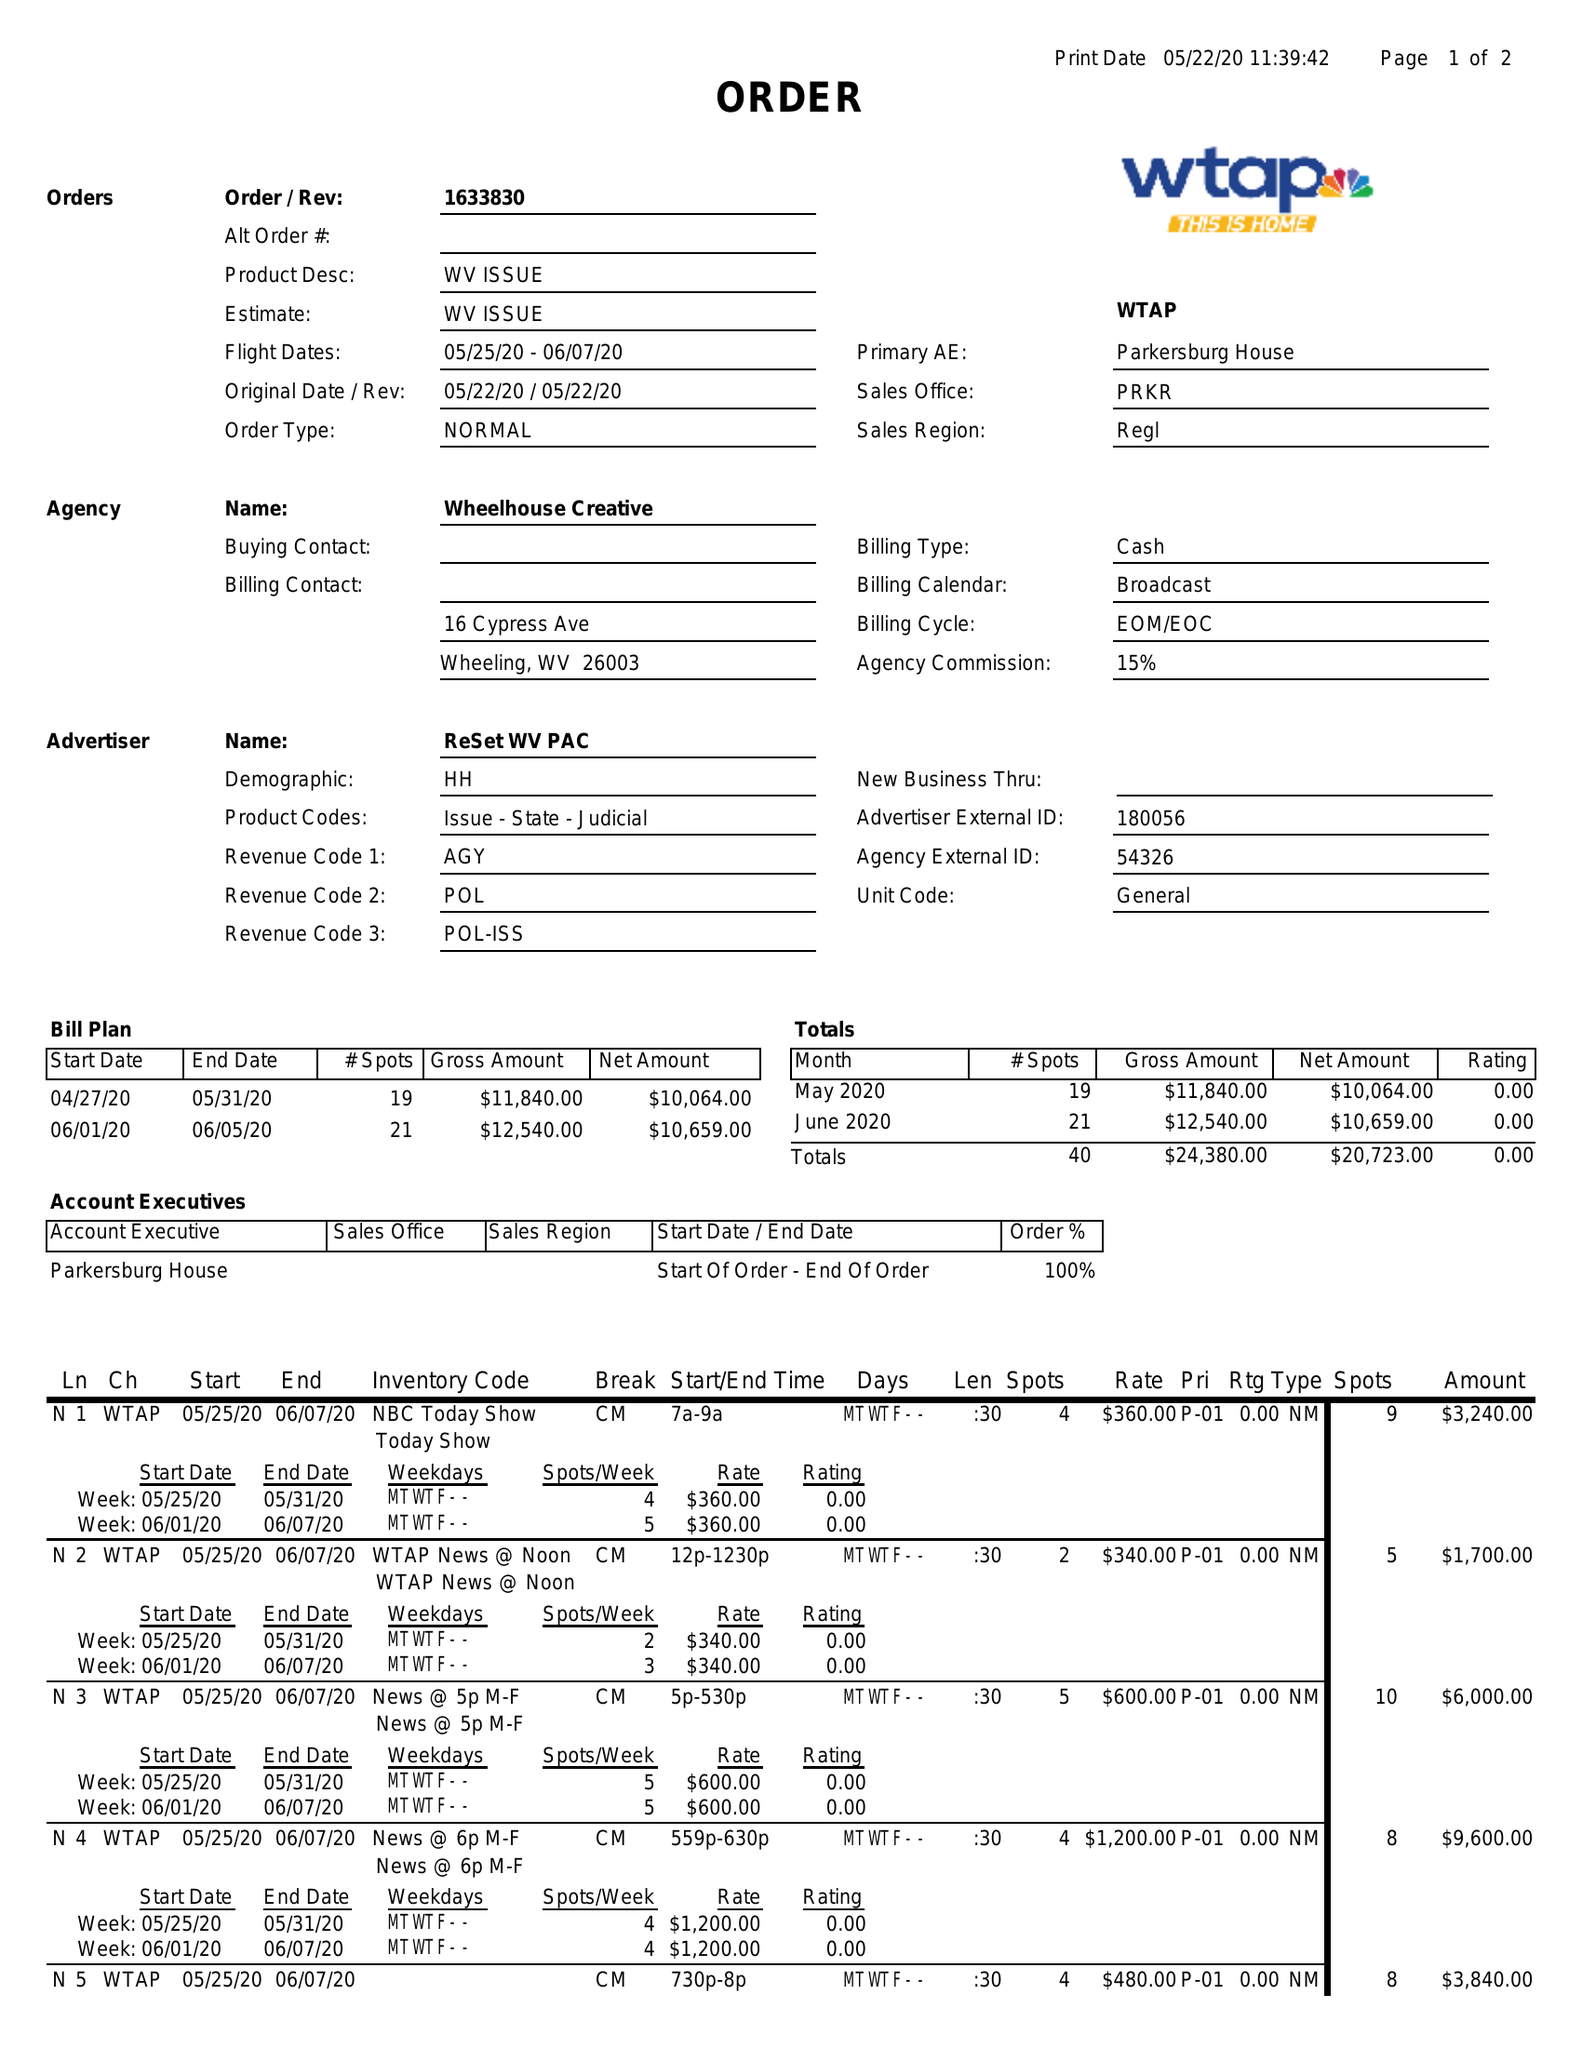What is the value for the advertiser?
Answer the question using a single word or phrase. RESET WV PAC 